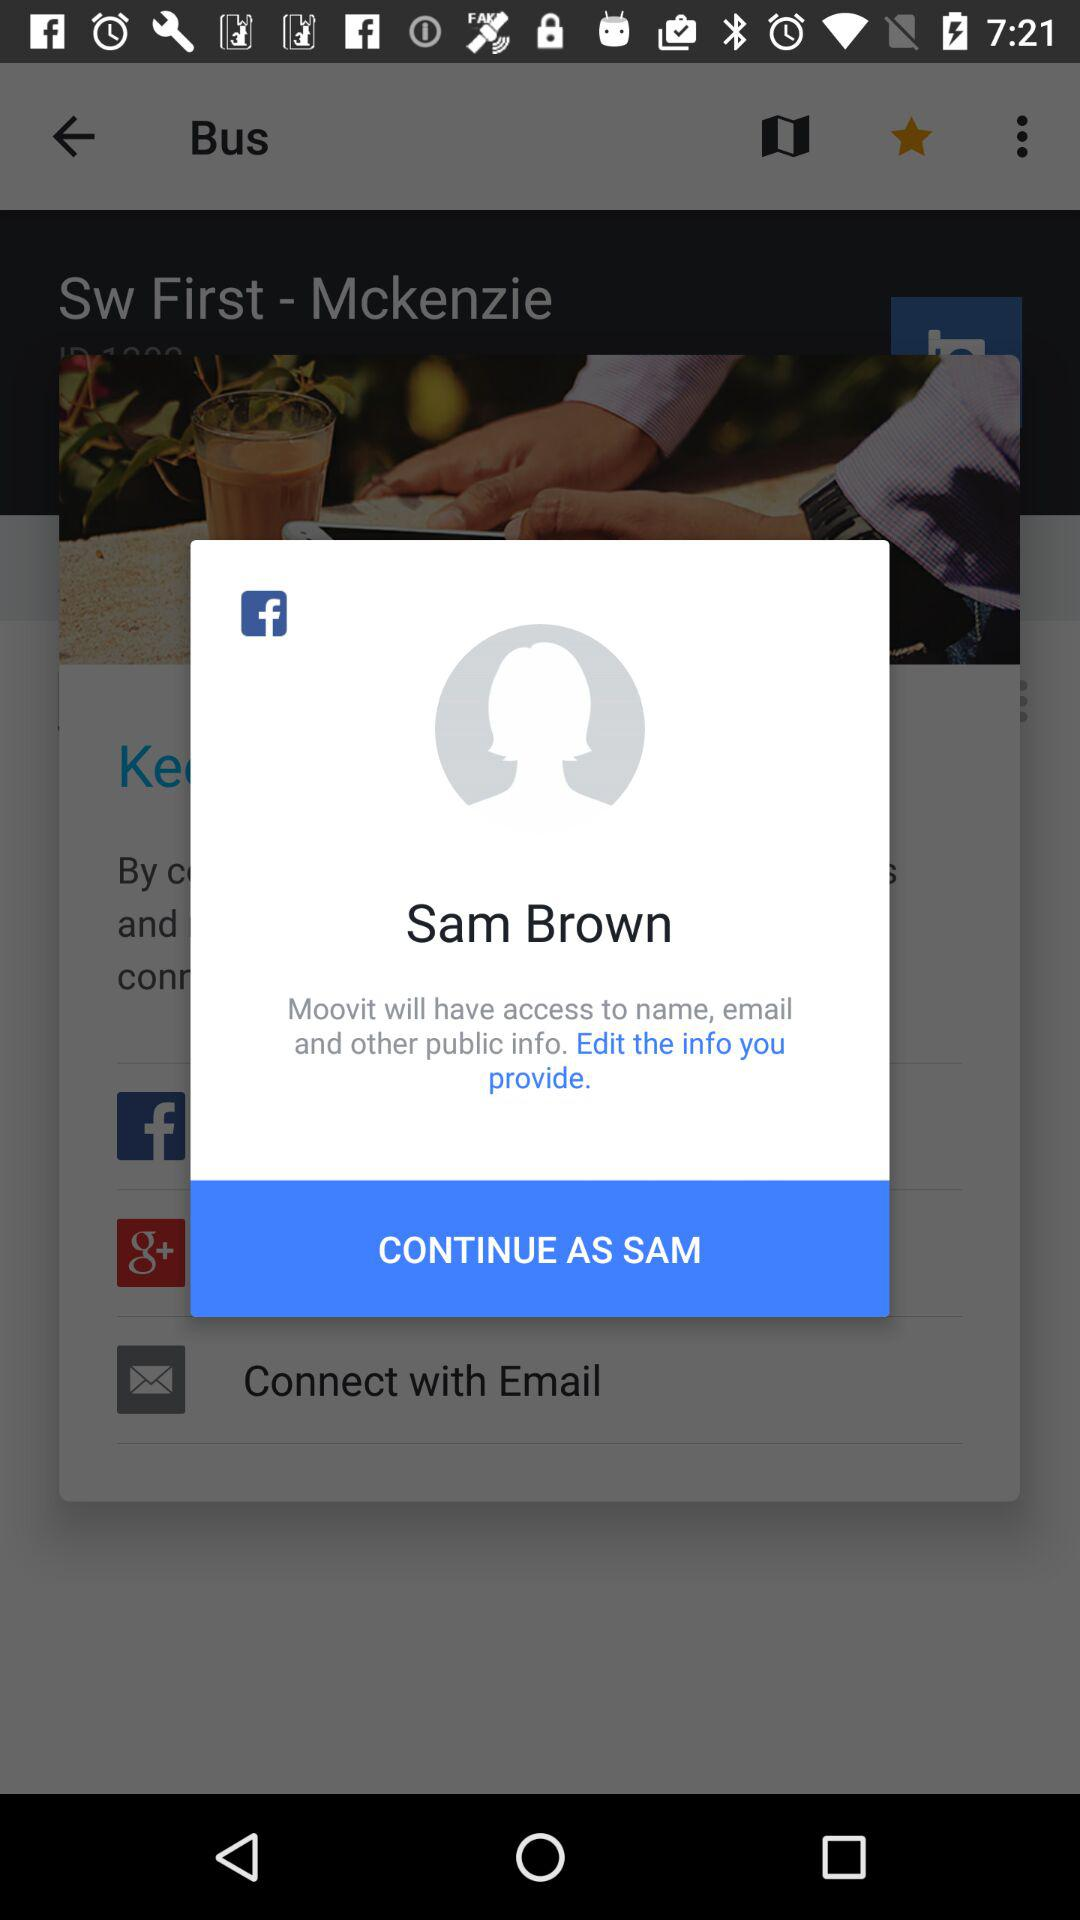What is the name of the application that can be used to continue the login? The application that can be used to continue the login is "Facebook". 